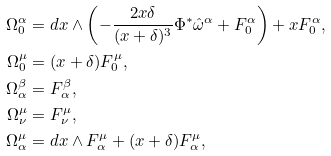Convert formula to latex. <formula><loc_0><loc_0><loc_500><loc_500>\Omega ^ { \alpha } _ { 0 } & = d x \wedge \left ( - \frac { 2 x \delta } { ( x + \delta ) ^ { 3 } } \Phi ^ { * } \hat { \omega } ^ { \alpha } + F ^ { \alpha } _ { 0 } \right ) + x F ^ { \alpha } _ { 0 } , \\ \Omega ^ { \mu } _ { 0 } & = ( x + \delta ) F ^ { \mu } _ { 0 } , \\ \Omega ^ { \beta } _ { \alpha } & = F ^ { \beta } _ { \alpha } , \\ \Omega ^ { \mu } _ { \nu } & = F ^ { \mu } _ { \nu } , \\ \Omega ^ { \mu } _ { \alpha } & = d x \wedge F ^ { \mu } _ { \alpha } + ( x + \delta ) F ^ { \mu } _ { \alpha } ,</formula> 